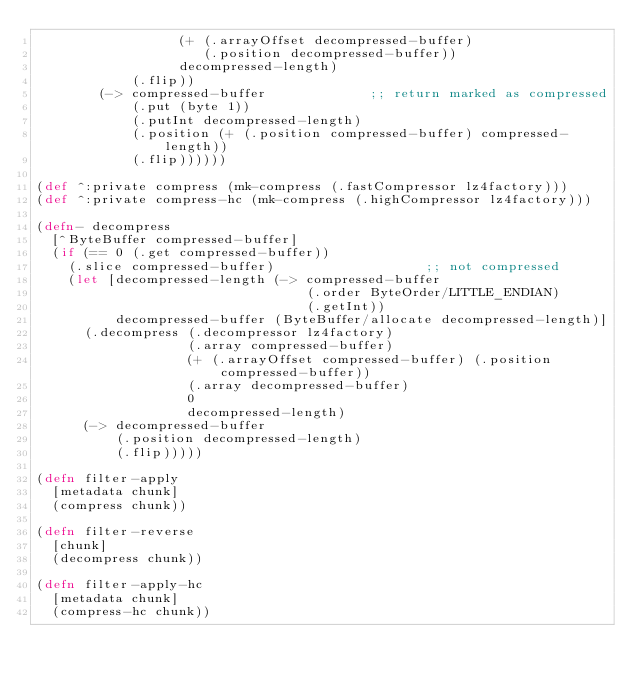Convert code to text. <code><loc_0><loc_0><loc_500><loc_500><_Clojure_>                  (+ (.arrayOffset decompressed-buffer)
                     (.position decompressed-buffer))
                  decompressed-length)
            (.flip))
        (-> compressed-buffer             ;; return marked as compressed
            (.put (byte 1))
            (.putInt decompressed-length)
            (.position (+ (.position compressed-buffer) compressed-length))
            (.flip))))))

(def ^:private compress (mk-compress (.fastCompressor lz4factory)))
(def ^:private compress-hc (mk-compress (.highCompressor lz4factory)))

(defn- decompress
  [^ByteBuffer compressed-buffer]
  (if (== 0 (.get compressed-buffer))
    (.slice compressed-buffer)                   ;; not compressed
    (let [decompressed-length (-> compressed-buffer
                                  (.order ByteOrder/LITTLE_ENDIAN)
                                  (.getInt))
          decompressed-buffer (ByteBuffer/allocate decompressed-length)]
      (.decompress (.decompressor lz4factory)
                   (.array compressed-buffer)
                   (+ (.arrayOffset compressed-buffer) (.position compressed-buffer))
                   (.array decompressed-buffer)
                   0
                   decompressed-length)
      (-> decompressed-buffer
          (.position decompressed-length)
          (.flip)))))

(defn filter-apply
  [metadata chunk]
  (compress chunk))

(defn filter-reverse
  [chunk]
  (decompress chunk))

(defn filter-apply-hc
  [metadata chunk]
  (compress-hc chunk))
</code> 